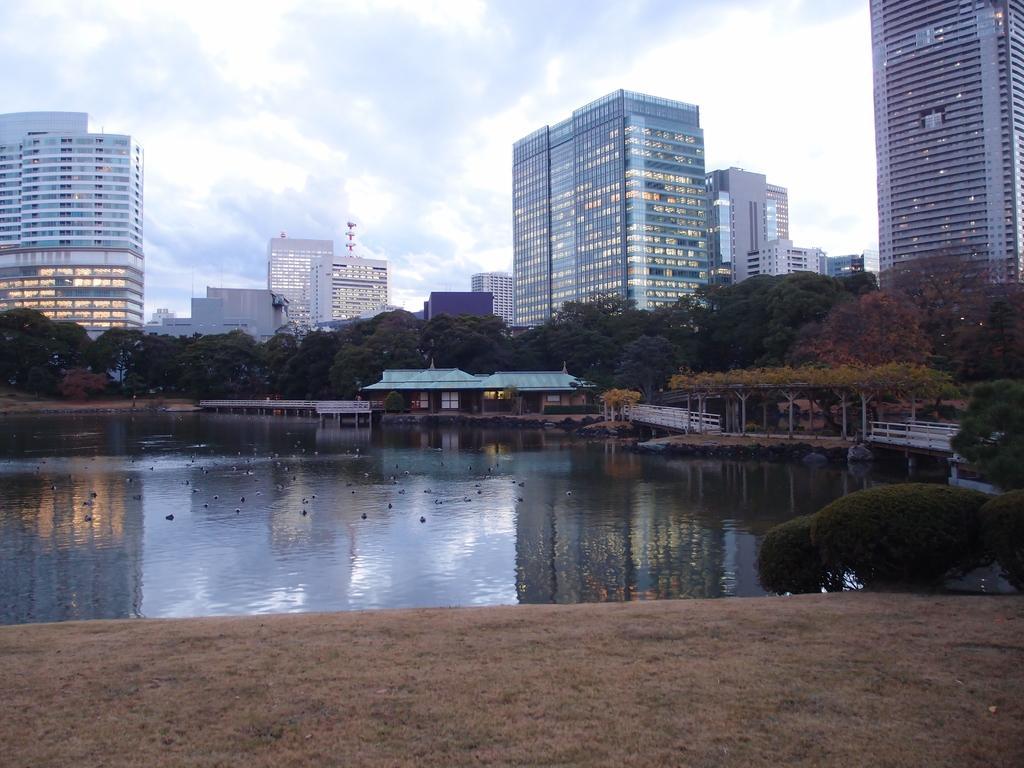Can you describe this image briefly? This picture shows buildings trees and we see water and a blue cloudy Sky. 